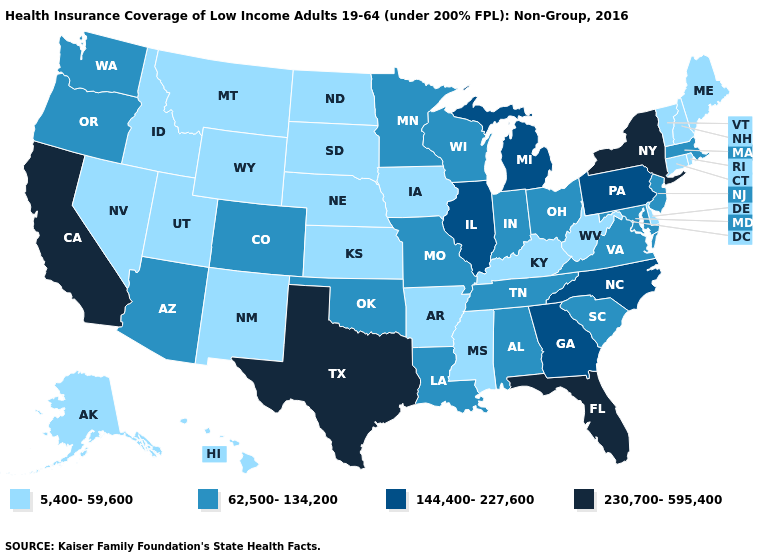Does Alaska have the lowest value in the USA?
Be succinct. Yes. Among the states that border Florida , which have the highest value?
Write a very short answer. Georgia. Name the states that have a value in the range 62,500-134,200?
Give a very brief answer. Alabama, Arizona, Colorado, Indiana, Louisiana, Maryland, Massachusetts, Minnesota, Missouri, New Jersey, Ohio, Oklahoma, Oregon, South Carolina, Tennessee, Virginia, Washington, Wisconsin. What is the value of New Jersey?
Concise answer only. 62,500-134,200. Name the states that have a value in the range 144,400-227,600?
Keep it brief. Georgia, Illinois, Michigan, North Carolina, Pennsylvania. Among the states that border Arkansas , does Oklahoma have the highest value?
Answer briefly. No. Among the states that border Rhode Island , does Connecticut have the highest value?
Keep it brief. No. What is the highest value in the USA?
Write a very short answer. 230,700-595,400. Name the states that have a value in the range 230,700-595,400?
Concise answer only. California, Florida, New York, Texas. What is the highest value in the USA?
Be succinct. 230,700-595,400. Is the legend a continuous bar?
Answer briefly. No. Name the states that have a value in the range 230,700-595,400?
Concise answer only. California, Florida, New York, Texas. How many symbols are there in the legend?
Answer briefly. 4. Name the states that have a value in the range 62,500-134,200?
Keep it brief. Alabama, Arizona, Colorado, Indiana, Louisiana, Maryland, Massachusetts, Minnesota, Missouri, New Jersey, Ohio, Oklahoma, Oregon, South Carolina, Tennessee, Virginia, Washington, Wisconsin. What is the lowest value in the USA?
Quick response, please. 5,400-59,600. 